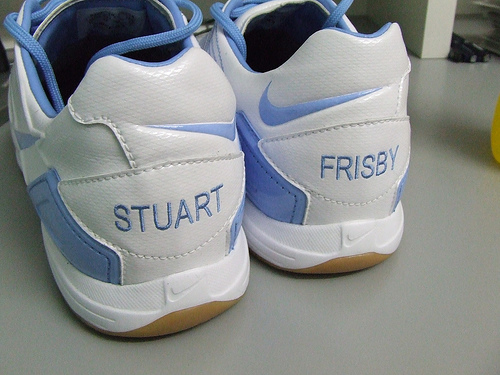<image>
Is there a shoe next to the floor? No. The shoe is not positioned next to the floor. They are located in different areas of the scene. Where is the slippers in relation to the floor? Is it in the floor? No. The slippers is not contained within the floor. These objects have a different spatial relationship. 